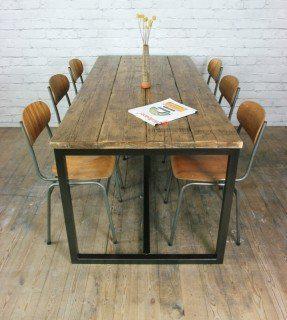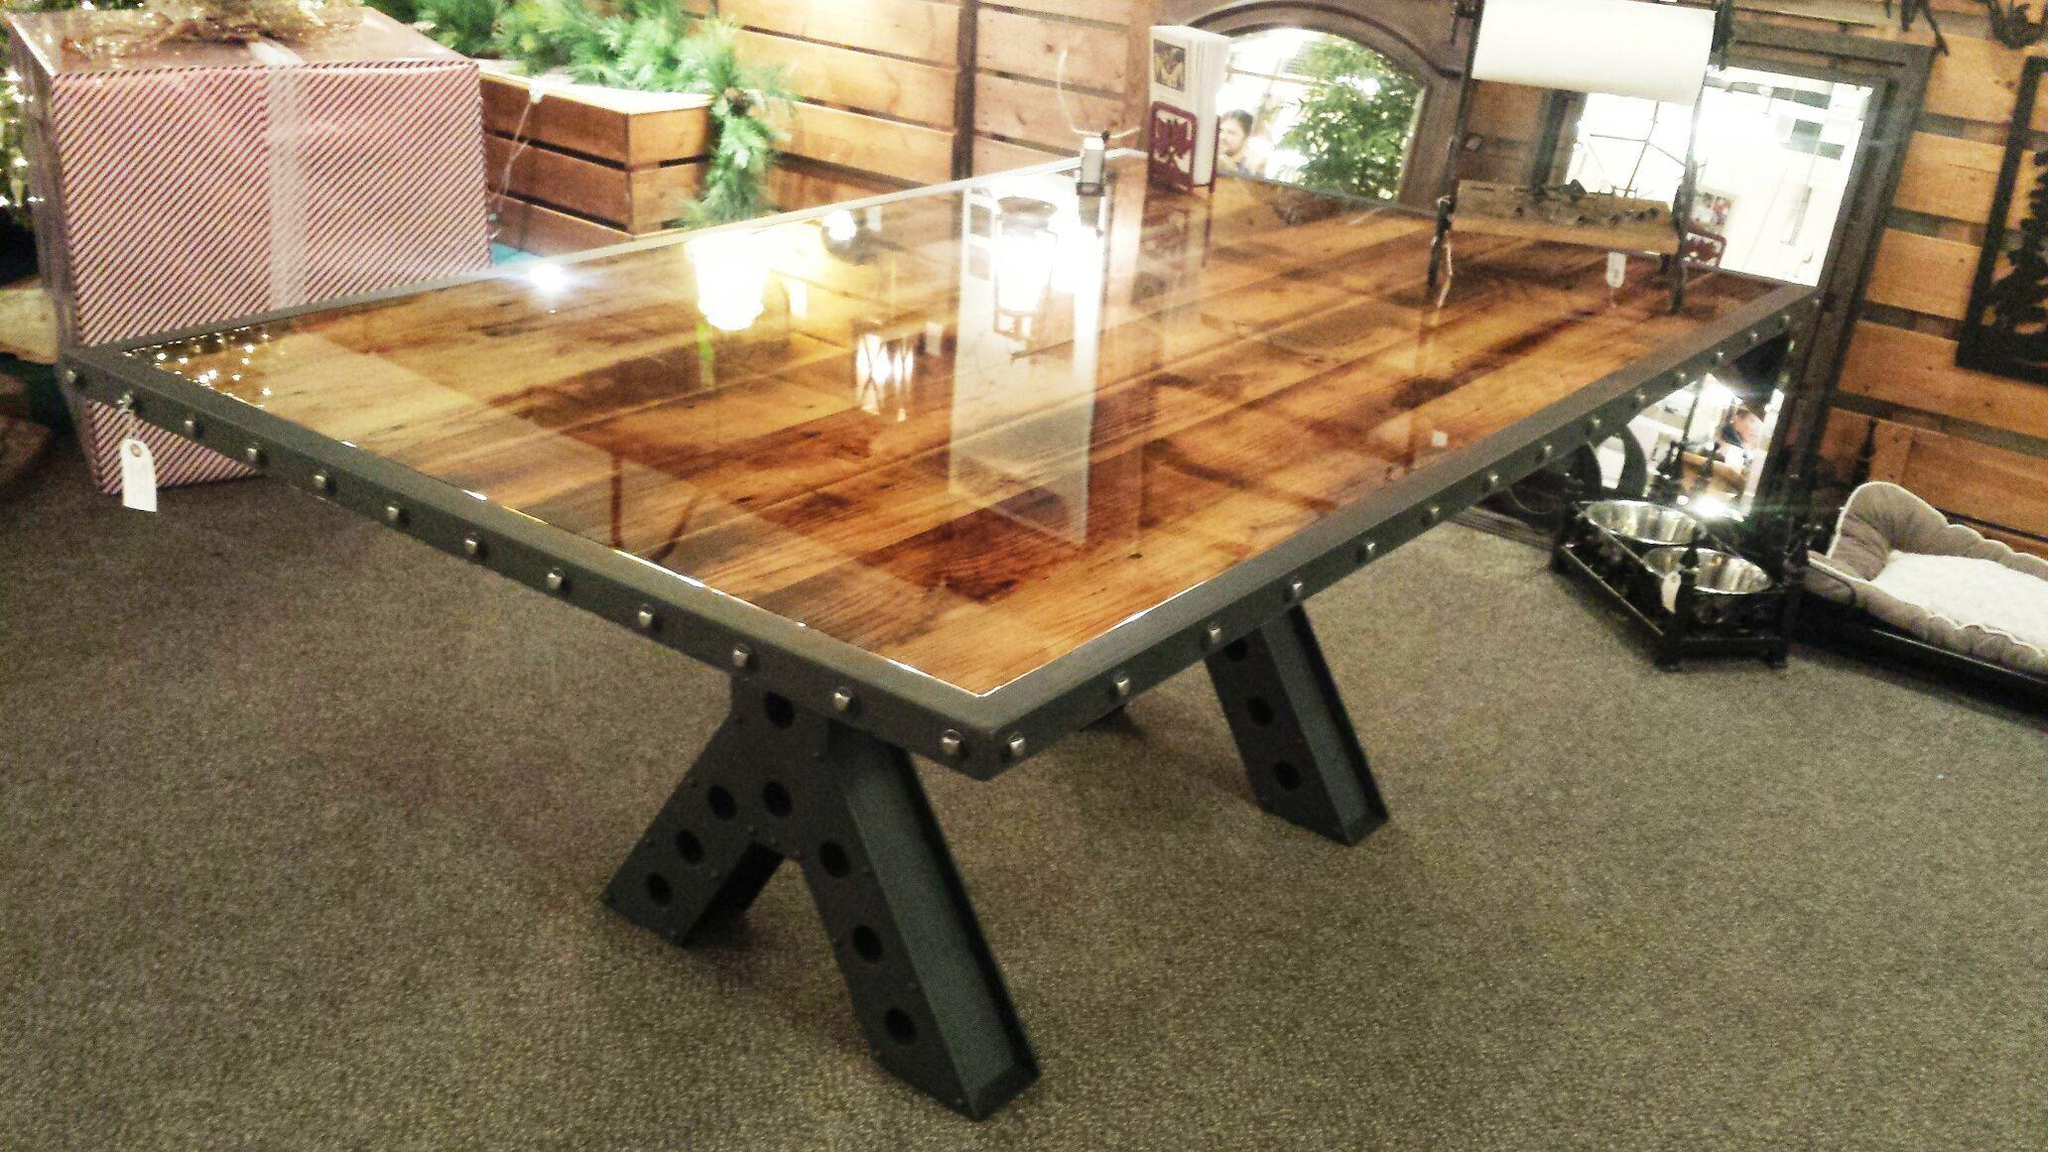The first image is the image on the left, the second image is the image on the right. Examine the images to the left and right. Is the description "There is a vase with flowers in the image on the left." accurate? Answer yes or no. Yes. 